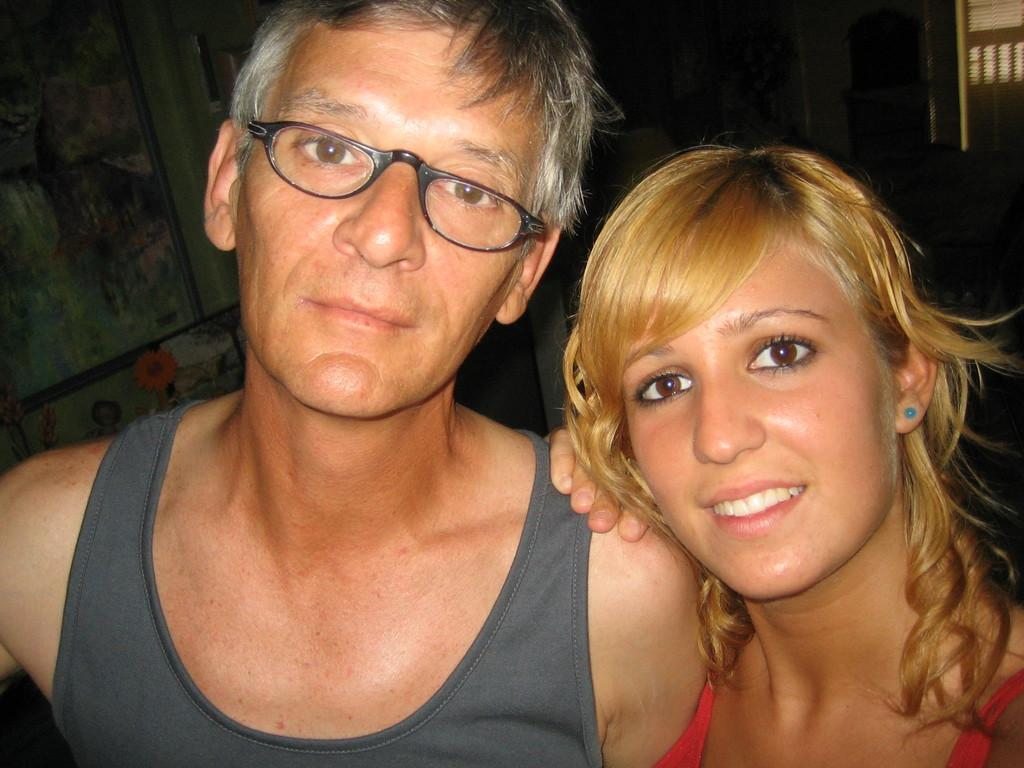How many people are in the foreground of the image? There are two persons in the foreground of the image. What are the two persons doing in the image? The two persons appear to be standing. What can be seen in the background of the image? There are many other objects visible in the background of the image. Where can the goldfish be found in the image? There are no goldfish present in the image. What type of trousers is the person on the left wearing in the image? The provided facts do not give us enough information to determine the type of trousers the person on the left is wearing. 